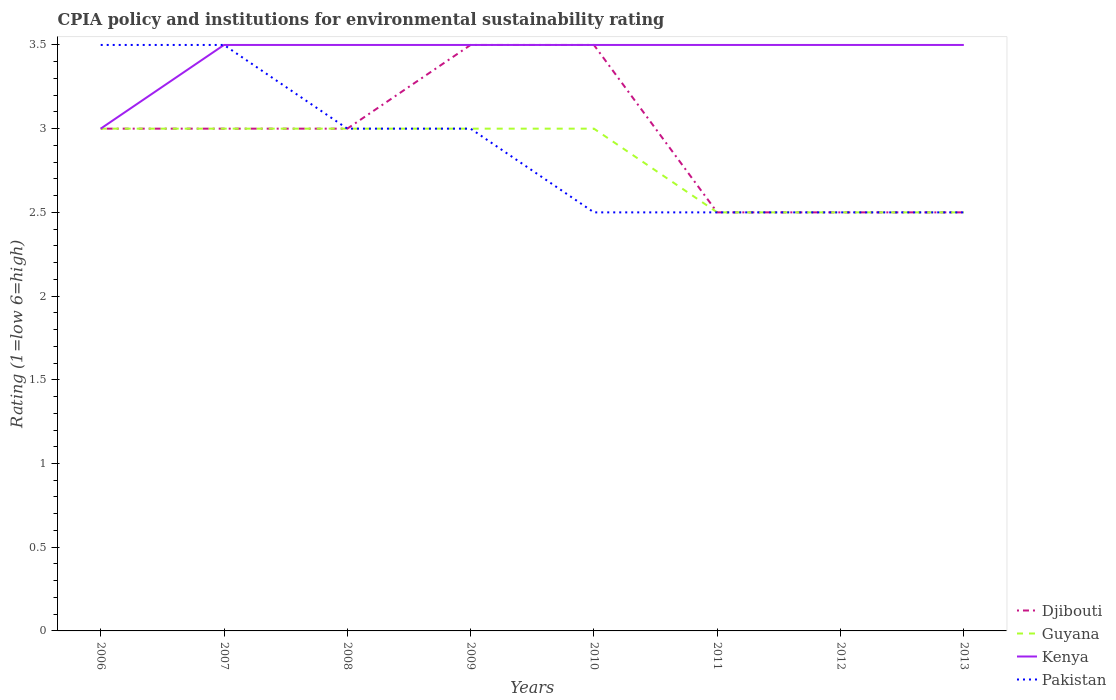How many different coloured lines are there?
Give a very brief answer. 4. Across all years, what is the maximum CPIA rating in Pakistan?
Your response must be concise. 2.5. What is the total CPIA rating in Guyana in the graph?
Give a very brief answer. 0. How many lines are there?
Give a very brief answer. 4. Are the values on the major ticks of Y-axis written in scientific E-notation?
Your response must be concise. No. Does the graph contain grids?
Provide a succinct answer. No. Where does the legend appear in the graph?
Give a very brief answer. Bottom right. How are the legend labels stacked?
Ensure brevity in your answer.  Vertical. What is the title of the graph?
Give a very brief answer. CPIA policy and institutions for environmental sustainability rating. Does "Morocco" appear as one of the legend labels in the graph?
Ensure brevity in your answer.  No. What is the label or title of the X-axis?
Provide a succinct answer. Years. What is the Rating (1=low 6=high) of Guyana in 2007?
Ensure brevity in your answer.  3. What is the Rating (1=low 6=high) in Pakistan in 2007?
Provide a succinct answer. 3.5. What is the Rating (1=low 6=high) in Djibouti in 2009?
Offer a very short reply. 3.5. What is the Rating (1=low 6=high) in Guyana in 2009?
Your answer should be compact. 3. What is the Rating (1=low 6=high) in Kenya in 2009?
Give a very brief answer. 3.5. What is the Rating (1=low 6=high) in Djibouti in 2010?
Provide a succinct answer. 3.5. What is the Rating (1=low 6=high) of Guyana in 2010?
Ensure brevity in your answer.  3. What is the Rating (1=low 6=high) in Djibouti in 2011?
Your answer should be very brief. 2.5. What is the Rating (1=low 6=high) in Guyana in 2011?
Keep it short and to the point. 2.5. What is the Rating (1=low 6=high) of Pakistan in 2011?
Your answer should be very brief. 2.5. What is the Rating (1=low 6=high) of Djibouti in 2013?
Your answer should be compact. 2.5. What is the Rating (1=low 6=high) of Guyana in 2013?
Make the answer very short. 2.5. What is the Rating (1=low 6=high) of Pakistan in 2013?
Ensure brevity in your answer.  2.5. Across all years, what is the maximum Rating (1=low 6=high) of Djibouti?
Your response must be concise. 3.5. Across all years, what is the maximum Rating (1=low 6=high) in Guyana?
Give a very brief answer. 3. Across all years, what is the minimum Rating (1=low 6=high) of Guyana?
Your answer should be very brief. 2.5. Across all years, what is the minimum Rating (1=low 6=high) of Kenya?
Your response must be concise. 3. What is the total Rating (1=low 6=high) of Djibouti in the graph?
Provide a succinct answer. 23.5. What is the total Rating (1=low 6=high) of Kenya in the graph?
Provide a short and direct response. 27.5. What is the difference between the Rating (1=low 6=high) in Djibouti in 2006 and that in 2007?
Offer a terse response. 0. What is the difference between the Rating (1=low 6=high) in Guyana in 2006 and that in 2007?
Offer a very short reply. 0. What is the difference between the Rating (1=low 6=high) of Pakistan in 2006 and that in 2007?
Offer a terse response. 0. What is the difference between the Rating (1=low 6=high) of Guyana in 2006 and that in 2008?
Your answer should be compact. 0. What is the difference between the Rating (1=low 6=high) of Pakistan in 2006 and that in 2008?
Offer a terse response. 0.5. What is the difference between the Rating (1=low 6=high) in Kenya in 2006 and that in 2009?
Provide a short and direct response. -0.5. What is the difference between the Rating (1=low 6=high) of Pakistan in 2006 and that in 2009?
Your answer should be very brief. 0.5. What is the difference between the Rating (1=low 6=high) of Guyana in 2006 and that in 2010?
Provide a short and direct response. 0. What is the difference between the Rating (1=low 6=high) in Kenya in 2006 and that in 2010?
Offer a terse response. -0.5. What is the difference between the Rating (1=low 6=high) in Guyana in 2006 and that in 2011?
Provide a succinct answer. 0.5. What is the difference between the Rating (1=low 6=high) in Kenya in 2006 and that in 2011?
Give a very brief answer. -0.5. What is the difference between the Rating (1=low 6=high) of Kenya in 2006 and that in 2012?
Ensure brevity in your answer.  -0.5. What is the difference between the Rating (1=low 6=high) in Kenya in 2006 and that in 2013?
Your answer should be compact. -0.5. What is the difference between the Rating (1=low 6=high) of Pakistan in 2006 and that in 2013?
Offer a terse response. 1. What is the difference between the Rating (1=low 6=high) in Kenya in 2007 and that in 2008?
Provide a succinct answer. 0. What is the difference between the Rating (1=low 6=high) in Pakistan in 2007 and that in 2008?
Provide a succinct answer. 0.5. What is the difference between the Rating (1=low 6=high) in Djibouti in 2007 and that in 2009?
Offer a very short reply. -0.5. What is the difference between the Rating (1=low 6=high) in Guyana in 2007 and that in 2009?
Offer a terse response. 0. What is the difference between the Rating (1=low 6=high) in Kenya in 2007 and that in 2009?
Your answer should be very brief. 0. What is the difference between the Rating (1=low 6=high) in Guyana in 2007 and that in 2010?
Ensure brevity in your answer.  0. What is the difference between the Rating (1=low 6=high) of Kenya in 2007 and that in 2010?
Offer a terse response. 0. What is the difference between the Rating (1=low 6=high) of Djibouti in 2007 and that in 2011?
Provide a succinct answer. 0.5. What is the difference between the Rating (1=low 6=high) in Guyana in 2007 and that in 2011?
Your answer should be compact. 0.5. What is the difference between the Rating (1=low 6=high) in Pakistan in 2007 and that in 2011?
Your answer should be very brief. 1. What is the difference between the Rating (1=low 6=high) of Guyana in 2007 and that in 2012?
Keep it short and to the point. 0.5. What is the difference between the Rating (1=low 6=high) in Djibouti in 2007 and that in 2013?
Your answer should be very brief. 0.5. What is the difference between the Rating (1=low 6=high) in Kenya in 2007 and that in 2013?
Provide a short and direct response. 0. What is the difference between the Rating (1=low 6=high) of Pakistan in 2008 and that in 2010?
Offer a terse response. 0.5. What is the difference between the Rating (1=low 6=high) of Guyana in 2008 and that in 2011?
Provide a short and direct response. 0.5. What is the difference between the Rating (1=low 6=high) in Kenya in 2008 and that in 2011?
Provide a short and direct response. 0. What is the difference between the Rating (1=low 6=high) of Djibouti in 2008 and that in 2012?
Make the answer very short. 0.5. What is the difference between the Rating (1=low 6=high) in Guyana in 2008 and that in 2012?
Your answer should be compact. 0.5. What is the difference between the Rating (1=low 6=high) in Pakistan in 2008 and that in 2012?
Offer a very short reply. 0.5. What is the difference between the Rating (1=low 6=high) of Djibouti in 2008 and that in 2013?
Your answer should be compact. 0.5. What is the difference between the Rating (1=low 6=high) in Kenya in 2008 and that in 2013?
Provide a succinct answer. 0. What is the difference between the Rating (1=low 6=high) in Pakistan in 2008 and that in 2013?
Keep it short and to the point. 0.5. What is the difference between the Rating (1=low 6=high) in Pakistan in 2009 and that in 2010?
Give a very brief answer. 0.5. What is the difference between the Rating (1=low 6=high) in Kenya in 2009 and that in 2011?
Give a very brief answer. 0. What is the difference between the Rating (1=low 6=high) in Guyana in 2009 and that in 2012?
Give a very brief answer. 0.5. What is the difference between the Rating (1=low 6=high) of Guyana in 2009 and that in 2013?
Provide a succinct answer. 0.5. What is the difference between the Rating (1=low 6=high) of Kenya in 2009 and that in 2013?
Your response must be concise. 0. What is the difference between the Rating (1=low 6=high) of Pakistan in 2009 and that in 2013?
Your answer should be compact. 0.5. What is the difference between the Rating (1=low 6=high) of Djibouti in 2010 and that in 2011?
Offer a terse response. 1. What is the difference between the Rating (1=low 6=high) of Djibouti in 2010 and that in 2013?
Offer a terse response. 1. What is the difference between the Rating (1=low 6=high) in Kenya in 2010 and that in 2013?
Keep it short and to the point. 0. What is the difference between the Rating (1=low 6=high) in Kenya in 2011 and that in 2012?
Make the answer very short. 0. What is the difference between the Rating (1=low 6=high) in Kenya in 2011 and that in 2013?
Your answer should be very brief. 0. What is the difference between the Rating (1=low 6=high) in Djibouti in 2012 and that in 2013?
Keep it short and to the point. 0. What is the difference between the Rating (1=low 6=high) of Djibouti in 2006 and the Rating (1=low 6=high) of Guyana in 2007?
Keep it short and to the point. 0. What is the difference between the Rating (1=low 6=high) of Kenya in 2006 and the Rating (1=low 6=high) of Pakistan in 2007?
Ensure brevity in your answer.  -0.5. What is the difference between the Rating (1=low 6=high) in Djibouti in 2006 and the Rating (1=low 6=high) in Kenya in 2008?
Offer a terse response. -0.5. What is the difference between the Rating (1=low 6=high) of Djibouti in 2006 and the Rating (1=low 6=high) of Pakistan in 2008?
Give a very brief answer. 0. What is the difference between the Rating (1=low 6=high) of Guyana in 2006 and the Rating (1=low 6=high) of Kenya in 2008?
Your answer should be very brief. -0.5. What is the difference between the Rating (1=low 6=high) in Guyana in 2006 and the Rating (1=low 6=high) in Pakistan in 2008?
Provide a short and direct response. 0. What is the difference between the Rating (1=low 6=high) of Djibouti in 2006 and the Rating (1=low 6=high) of Kenya in 2009?
Offer a terse response. -0.5. What is the difference between the Rating (1=low 6=high) in Guyana in 2006 and the Rating (1=low 6=high) in Pakistan in 2009?
Keep it short and to the point. 0. What is the difference between the Rating (1=low 6=high) in Djibouti in 2006 and the Rating (1=low 6=high) in Pakistan in 2010?
Provide a short and direct response. 0.5. What is the difference between the Rating (1=low 6=high) in Guyana in 2006 and the Rating (1=low 6=high) in Pakistan in 2010?
Make the answer very short. 0.5. What is the difference between the Rating (1=low 6=high) in Djibouti in 2006 and the Rating (1=low 6=high) in Guyana in 2011?
Make the answer very short. 0.5. What is the difference between the Rating (1=low 6=high) in Djibouti in 2006 and the Rating (1=low 6=high) in Kenya in 2011?
Ensure brevity in your answer.  -0.5. What is the difference between the Rating (1=low 6=high) of Djibouti in 2006 and the Rating (1=low 6=high) of Kenya in 2012?
Ensure brevity in your answer.  -0.5. What is the difference between the Rating (1=low 6=high) of Djibouti in 2006 and the Rating (1=low 6=high) of Pakistan in 2012?
Your response must be concise. 0.5. What is the difference between the Rating (1=low 6=high) of Guyana in 2006 and the Rating (1=low 6=high) of Kenya in 2012?
Your answer should be very brief. -0.5. What is the difference between the Rating (1=low 6=high) in Djibouti in 2006 and the Rating (1=low 6=high) in Guyana in 2013?
Ensure brevity in your answer.  0.5. What is the difference between the Rating (1=low 6=high) of Djibouti in 2006 and the Rating (1=low 6=high) of Kenya in 2013?
Ensure brevity in your answer.  -0.5. What is the difference between the Rating (1=low 6=high) of Djibouti in 2006 and the Rating (1=low 6=high) of Pakistan in 2013?
Offer a very short reply. 0.5. What is the difference between the Rating (1=low 6=high) of Kenya in 2006 and the Rating (1=low 6=high) of Pakistan in 2013?
Provide a short and direct response. 0.5. What is the difference between the Rating (1=low 6=high) in Djibouti in 2007 and the Rating (1=low 6=high) in Guyana in 2008?
Offer a terse response. 0. What is the difference between the Rating (1=low 6=high) of Djibouti in 2007 and the Rating (1=low 6=high) of Kenya in 2008?
Your response must be concise. -0.5. What is the difference between the Rating (1=low 6=high) of Djibouti in 2007 and the Rating (1=low 6=high) of Pakistan in 2008?
Offer a terse response. 0. What is the difference between the Rating (1=low 6=high) of Kenya in 2007 and the Rating (1=low 6=high) of Pakistan in 2008?
Offer a very short reply. 0.5. What is the difference between the Rating (1=low 6=high) of Djibouti in 2007 and the Rating (1=low 6=high) of Pakistan in 2009?
Provide a short and direct response. 0. What is the difference between the Rating (1=low 6=high) of Guyana in 2007 and the Rating (1=low 6=high) of Pakistan in 2009?
Your answer should be compact. 0. What is the difference between the Rating (1=low 6=high) of Djibouti in 2007 and the Rating (1=low 6=high) of Guyana in 2010?
Keep it short and to the point. 0. What is the difference between the Rating (1=low 6=high) in Djibouti in 2007 and the Rating (1=low 6=high) in Pakistan in 2010?
Your answer should be very brief. 0.5. What is the difference between the Rating (1=low 6=high) in Djibouti in 2007 and the Rating (1=low 6=high) in Kenya in 2011?
Make the answer very short. -0.5. What is the difference between the Rating (1=low 6=high) in Djibouti in 2007 and the Rating (1=low 6=high) in Pakistan in 2011?
Your answer should be compact. 0.5. What is the difference between the Rating (1=low 6=high) of Guyana in 2007 and the Rating (1=low 6=high) of Kenya in 2011?
Offer a terse response. -0.5. What is the difference between the Rating (1=low 6=high) in Guyana in 2007 and the Rating (1=low 6=high) in Pakistan in 2011?
Your answer should be compact. 0.5. What is the difference between the Rating (1=low 6=high) of Djibouti in 2007 and the Rating (1=low 6=high) of Guyana in 2012?
Provide a short and direct response. 0.5. What is the difference between the Rating (1=low 6=high) in Djibouti in 2007 and the Rating (1=low 6=high) in Kenya in 2012?
Your response must be concise. -0.5. What is the difference between the Rating (1=low 6=high) of Kenya in 2007 and the Rating (1=low 6=high) of Pakistan in 2012?
Your answer should be compact. 1. What is the difference between the Rating (1=low 6=high) in Djibouti in 2007 and the Rating (1=low 6=high) in Kenya in 2013?
Give a very brief answer. -0.5. What is the difference between the Rating (1=low 6=high) in Djibouti in 2007 and the Rating (1=low 6=high) in Pakistan in 2013?
Provide a short and direct response. 0.5. What is the difference between the Rating (1=low 6=high) of Guyana in 2007 and the Rating (1=low 6=high) of Pakistan in 2013?
Provide a succinct answer. 0.5. What is the difference between the Rating (1=low 6=high) of Djibouti in 2008 and the Rating (1=low 6=high) of Guyana in 2009?
Your response must be concise. 0. What is the difference between the Rating (1=low 6=high) in Djibouti in 2008 and the Rating (1=low 6=high) in Kenya in 2009?
Ensure brevity in your answer.  -0.5. What is the difference between the Rating (1=low 6=high) of Djibouti in 2008 and the Rating (1=low 6=high) of Pakistan in 2009?
Ensure brevity in your answer.  0. What is the difference between the Rating (1=low 6=high) in Guyana in 2008 and the Rating (1=low 6=high) in Kenya in 2009?
Your answer should be compact. -0.5. What is the difference between the Rating (1=low 6=high) in Kenya in 2008 and the Rating (1=low 6=high) in Pakistan in 2009?
Keep it short and to the point. 0.5. What is the difference between the Rating (1=low 6=high) of Djibouti in 2008 and the Rating (1=low 6=high) of Kenya in 2010?
Offer a very short reply. -0.5. What is the difference between the Rating (1=low 6=high) of Guyana in 2008 and the Rating (1=low 6=high) of Pakistan in 2010?
Your answer should be compact. 0.5. What is the difference between the Rating (1=low 6=high) in Kenya in 2008 and the Rating (1=low 6=high) in Pakistan in 2010?
Your answer should be compact. 1. What is the difference between the Rating (1=low 6=high) of Djibouti in 2008 and the Rating (1=low 6=high) of Kenya in 2011?
Give a very brief answer. -0.5. What is the difference between the Rating (1=low 6=high) in Guyana in 2008 and the Rating (1=low 6=high) in Pakistan in 2012?
Offer a terse response. 0.5. What is the difference between the Rating (1=low 6=high) in Djibouti in 2008 and the Rating (1=low 6=high) in Kenya in 2013?
Your answer should be compact. -0.5. What is the difference between the Rating (1=low 6=high) of Kenya in 2008 and the Rating (1=low 6=high) of Pakistan in 2013?
Your answer should be compact. 1. What is the difference between the Rating (1=low 6=high) of Djibouti in 2009 and the Rating (1=low 6=high) of Pakistan in 2010?
Provide a succinct answer. 1. What is the difference between the Rating (1=low 6=high) of Kenya in 2009 and the Rating (1=low 6=high) of Pakistan in 2010?
Offer a terse response. 1. What is the difference between the Rating (1=low 6=high) in Djibouti in 2009 and the Rating (1=low 6=high) in Guyana in 2012?
Make the answer very short. 1. What is the difference between the Rating (1=low 6=high) of Guyana in 2009 and the Rating (1=low 6=high) of Kenya in 2012?
Provide a short and direct response. -0.5. What is the difference between the Rating (1=low 6=high) of Kenya in 2009 and the Rating (1=low 6=high) of Pakistan in 2012?
Offer a terse response. 1. What is the difference between the Rating (1=low 6=high) of Djibouti in 2009 and the Rating (1=low 6=high) of Guyana in 2013?
Give a very brief answer. 1. What is the difference between the Rating (1=low 6=high) of Djibouti in 2009 and the Rating (1=low 6=high) of Kenya in 2013?
Ensure brevity in your answer.  0. What is the difference between the Rating (1=low 6=high) in Djibouti in 2009 and the Rating (1=low 6=high) in Pakistan in 2013?
Make the answer very short. 1. What is the difference between the Rating (1=low 6=high) of Guyana in 2009 and the Rating (1=low 6=high) of Kenya in 2013?
Your answer should be very brief. -0.5. What is the difference between the Rating (1=low 6=high) in Kenya in 2009 and the Rating (1=low 6=high) in Pakistan in 2013?
Ensure brevity in your answer.  1. What is the difference between the Rating (1=low 6=high) in Djibouti in 2010 and the Rating (1=low 6=high) in Guyana in 2011?
Give a very brief answer. 1. What is the difference between the Rating (1=low 6=high) in Guyana in 2010 and the Rating (1=low 6=high) in Kenya in 2011?
Keep it short and to the point. -0.5. What is the difference between the Rating (1=low 6=high) of Guyana in 2010 and the Rating (1=low 6=high) of Pakistan in 2011?
Offer a very short reply. 0.5. What is the difference between the Rating (1=low 6=high) in Kenya in 2010 and the Rating (1=low 6=high) in Pakistan in 2011?
Provide a succinct answer. 1. What is the difference between the Rating (1=low 6=high) of Djibouti in 2010 and the Rating (1=low 6=high) of Guyana in 2012?
Make the answer very short. 1. What is the difference between the Rating (1=low 6=high) in Djibouti in 2010 and the Rating (1=low 6=high) in Kenya in 2012?
Your answer should be compact. 0. What is the difference between the Rating (1=low 6=high) in Guyana in 2010 and the Rating (1=low 6=high) in Kenya in 2012?
Provide a short and direct response. -0.5. What is the difference between the Rating (1=low 6=high) in Guyana in 2010 and the Rating (1=low 6=high) in Pakistan in 2012?
Provide a short and direct response. 0.5. What is the difference between the Rating (1=low 6=high) in Djibouti in 2010 and the Rating (1=low 6=high) in Guyana in 2013?
Keep it short and to the point. 1. What is the difference between the Rating (1=low 6=high) in Kenya in 2010 and the Rating (1=low 6=high) in Pakistan in 2013?
Make the answer very short. 1. What is the difference between the Rating (1=low 6=high) in Djibouti in 2011 and the Rating (1=low 6=high) in Kenya in 2012?
Make the answer very short. -1. What is the difference between the Rating (1=low 6=high) of Djibouti in 2011 and the Rating (1=low 6=high) of Pakistan in 2012?
Keep it short and to the point. 0. What is the difference between the Rating (1=low 6=high) in Kenya in 2011 and the Rating (1=low 6=high) in Pakistan in 2012?
Provide a succinct answer. 1. What is the difference between the Rating (1=low 6=high) of Djibouti in 2011 and the Rating (1=low 6=high) of Guyana in 2013?
Offer a terse response. 0. What is the difference between the Rating (1=low 6=high) in Djibouti in 2011 and the Rating (1=low 6=high) in Kenya in 2013?
Your answer should be very brief. -1. What is the difference between the Rating (1=low 6=high) of Djibouti in 2011 and the Rating (1=low 6=high) of Pakistan in 2013?
Ensure brevity in your answer.  0. What is the difference between the Rating (1=low 6=high) of Guyana in 2011 and the Rating (1=low 6=high) of Pakistan in 2013?
Offer a very short reply. 0. What is the difference between the Rating (1=low 6=high) of Djibouti in 2012 and the Rating (1=low 6=high) of Pakistan in 2013?
Ensure brevity in your answer.  0. What is the average Rating (1=low 6=high) of Djibouti per year?
Keep it short and to the point. 2.94. What is the average Rating (1=low 6=high) in Guyana per year?
Your answer should be compact. 2.81. What is the average Rating (1=low 6=high) of Kenya per year?
Offer a very short reply. 3.44. What is the average Rating (1=low 6=high) in Pakistan per year?
Ensure brevity in your answer.  2.88. In the year 2006, what is the difference between the Rating (1=low 6=high) in Djibouti and Rating (1=low 6=high) in Kenya?
Your answer should be very brief. 0. In the year 2006, what is the difference between the Rating (1=low 6=high) in Guyana and Rating (1=low 6=high) in Kenya?
Keep it short and to the point. 0. In the year 2006, what is the difference between the Rating (1=low 6=high) of Kenya and Rating (1=low 6=high) of Pakistan?
Make the answer very short. -0.5. In the year 2007, what is the difference between the Rating (1=low 6=high) of Djibouti and Rating (1=low 6=high) of Pakistan?
Provide a short and direct response. -0.5. In the year 2007, what is the difference between the Rating (1=low 6=high) in Guyana and Rating (1=low 6=high) in Kenya?
Ensure brevity in your answer.  -0.5. In the year 2008, what is the difference between the Rating (1=low 6=high) of Djibouti and Rating (1=low 6=high) of Kenya?
Provide a succinct answer. -0.5. In the year 2008, what is the difference between the Rating (1=low 6=high) in Guyana and Rating (1=low 6=high) in Pakistan?
Give a very brief answer. 0. In the year 2008, what is the difference between the Rating (1=low 6=high) in Kenya and Rating (1=low 6=high) in Pakistan?
Offer a very short reply. 0.5. In the year 2009, what is the difference between the Rating (1=low 6=high) in Djibouti and Rating (1=low 6=high) in Pakistan?
Provide a succinct answer. 0.5. In the year 2009, what is the difference between the Rating (1=low 6=high) of Guyana and Rating (1=low 6=high) of Kenya?
Your response must be concise. -0.5. In the year 2009, what is the difference between the Rating (1=low 6=high) of Guyana and Rating (1=low 6=high) of Pakistan?
Keep it short and to the point. 0. In the year 2010, what is the difference between the Rating (1=low 6=high) of Djibouti and Rating (1=low 6=high) of Kenya?
Ensure brevity in your answer.  0. In the year 2010, what is the difference between the Rating (1=low 6=high) of Guyana and Rating (1=low 6=high) of Pakistan?
Your answer should be very brief. 0.5. In the year 2010, what is the difference between the Rating (1=low 6=high) in Kenya and Rating (1=low 6=high) in Pakistan?
Make the answer very short. 1. In the year 2011, what is the difference between the Rating (1=low 6=high) of Djibouti and Rating (1=low 6=high) of Guyana?
Keep it short and to the point. 0. In the year 2011, what is the difference between the Rating (1=low 6=high) in Djibouti and Rating (1=low 6=high) in Kenya?
Offer a terse response. -1. In the year 2011, what is the difference between the Rating (1=low 6=high) of Guyana and Rating (1=low 6=high) of Kenya?
Provide a short and direct response. -1. In the year 2012, what is the difference between the Rating (1=low 6=high) of Djibouti and Rating (1=low 6=high) of Guyana?
Give a very brief answer. 0. In the year 2012, what is the difference between the Rating (1=low 6=high) in Djibouti and Rating (1=low 6=high) in Pakistan?
Make the answer very short. 0. In the year 2012, what is the difference between the Rating (1=low 6=high) in Kenya and Rating (1=low 6=high) in Pakistan?
Provide a short and direct response. 1. In the year 2013, what is the difference between the Rating (1=low 6=high) in Djibouti and Rating (1=low 6=high) in Kenya?
Ensure brevity in your answer.  -1. In the year 2013, what is the difference between the Rating (1=low 6=high) of Guyana and Rating (1=low 6=high) of Kenya?
Your answer should be very brief. -1. In the year 2013, what is the difference between the Rating (1=low 6=high) in Guyana and Rating (1=low 6=high) in Pakistan?
Keep it short and to the point. 0. In the year 2013, what is the difference between the Rating (1=low 6=high) of Kenya and Rating (1=low 6=high) of Pakistan?
Offer a very short reply. 1. What is the ratio of the Rating (1=low 6=high) of Djibouti in 2006 to that in 2007?
Offer a very short reply. 1. What is the ratio of the Rating (1=low 6=high) in Pakistan in 2006 to that in 2007?
Offer a very short reply. 1. What is the ratio of the Rating (1=low 6=high) in Pakistan in 2006 to that in 2008?
Provide a short and direct response. 1.17. What is the ratio of the Rating (1=low 6=high) in Djibouti in 2006 to that in 2009?
Offer a very short reply. 0.86. What is the ratio of the Rating (1=low 6=high) of Guyana in 2006 to that in 2009?
Keep it short and to the point. 1. What is the ratio of the Rating (1=low 6=high) in Kenya in 2006 to that in 2009?
Your answer should be compact. 0.86. What is the ratio of the Rating (1=low 6=high) in Kenya in 2006 to that in 2010?
Ensure brevity in your answer.  0.86. What is the ratio of the Rating (1=low 6=high) of Kenya in 2006 to that in 2011?
Provide a short and direct response. 0.86. What is the ratio of the Rating (1=low 6=high) of Pakistan in 2006 to that in 2011?
Make the answer very short. 1.4. What is the ratio of the Rating (1=low 6=high) of Djibouti in 2006 to that in 2012?
Offer a terse response. 1.2. What is the ratio of the Rating (1=low 6=high) of Pakistan in 2006 to that in 2012?
Ensure brevity in your answer.  1.4. What is the ratio of the Rating (1=low 6=high) in Djibouti in 2006 to that in 2013?
Your answer should be compact. 1.2. What is the ratio of the Rating (1=low 6=high) in Guyana in 2006 to that in 2013?
Make the answer very short. 1.2. What is the ratio of the Rating (1=low 6=high) of Guyana in 2007 to that in 2008?
Offer a terse response. 1. What is the ratio of the Rating (1=low 6=high) of Kenya in 2007 to that in 2008?
Offer a terse response. 1. What is the ratio of the Rating (1=low 6=high) in Djibouti in 2007 to that in 2009?
Ensure brevity in your answer.  0.86. What is the ratio of the Rating (1=low 6=high) in Kenya in 2007 to that in 2009?
Your response must be concise. 1. What is the ratio of the Rating (1=low 6=high) of Kenya in 2007 to that in 2010?
Your response must be concise. 1. What is the ratio of the Rating (1=low 6=high) in Djibouti in 2007 to that in 2011?
Your response must be concise. 1.2. What is the ratio of the Rating (1=low 6=high) of Guyana in 2007 to that in 2011?
Keep it short and to the point. 1.2. What is the ratio of the Rating (1=low 6=high) in Pakistan in 2007 to that in 2011?
Keep it short and to the point. 1.4. What is the ratio of the Rating (1=low 6=high) in Djibouti in 2007 to that in 2012?
Ensure brevity in your answer.  1.2. What is the ratio of the Rating (1=low 6=high) in Djibouti in 2007 to that in 2013?
Keep it short and to the point. 1.2. What is the ratio of the Rating (1=low 6=high) of Guyana in 2007 to that in 2013?
Your answer should be compact. 1.2. What is the ratio of the Rating (1=low 6=high) of Kenya in 2007 to that in 2013?
Make the answer very short. 1. What is the ratio of the Rating (1=low 6=high) of Pakistan in 2007 to that in 2013?
Give a very brief answer. 1.4. What is the ratio of the Rating (1=low 6=high) of Pakistan in 2008 to that in 2009?
Give a very brief answer. 1. What is the ratio of the Rating (1=low 6=high) of Djibouti in 2008 to that in 2010?
Your response must be concise. 0.86. What is the ratio of the Rating (1=low 6=high) in Guyana in 2008 to that in 2010?
Your answer should be compact. 1. What is the ratio of the Rating (1=low 6=high) in Kenya in 2008 to that in 2010?
Your answer should be very brief. 1. What is the ratio of the Rating (1=low 6=high) of Djibouti in 2008 to that in 2011?
Ensure brevity in your answer.  1.2. What is the ratio of the Rating (1=low 6=high) of Kenya in 2008 to that in 2011?
Keep it short and to the point. 1. What is the ratio of the Rating (1=low 6=high) in Djibouti in 2008 to that in 2012?
Your response must be concise. 1.2. What is the ratio of the Rating (1=low 6=high) of Kenya in 2008 to that in 2013?
Ensure brevity in your answer.  1. What is the ratio of the Rating (1=low 6=high) of Pakistan in 2008 to that in 2013?
Your answer should be very brief. 1.2. What is the ratio of the Rating (1=low 6=high) in Djibouti in 2009 to that in 2010?
Keep it short and to the point. 1. What is the ratio of the Rating (1=low 6=high) of Guyana in 2009 to that in 2010?
Give a very brief answer. 1. What is the ratio of the Rating (1=low 6=high) in Pakistan in 2009 to that in 2010?
Your answer should be very brief. 1.2. What is the ratio of the Rating (1=low 6=high) of Djibouti in 2009 to that in 2011?
Make the answer very short. 1.4. What is the ratio of the Rating (1=low 6=high) of Kenya in 2009 to that in 2011?
Give a very brief answer. 1. What is the ratio of the Rating (1=low 6=high) of Djibouti in 2009 to that in 2012?
Provide a succinct answer. 1.4. What is the ratio of the Rating (1=low 6=high) in Guyana in 2009 to that in 2012?
Provide a succinct answer. 1.2. What is the ratio of the Rating (1=low 6=high) of Kenya in 2009 to that in 2012?
Your answer should be compact. 1. What is the ratio of the Rating (1=low 6=high) of Pakistan in 2009 to that in 2012?
Provide a succinct answer. 1.2. What is the ratio of the Rating (1=low 6=high) of Kenya in 2010 to that in 2011?
Keep it short and to the point. 1. What is the ratio of the Rating (1=low 6=high) in Djibouti in 2010 to that in 2013?
Offer a very short reply. 1.4. What is the ratio of the Rating (1=low 6=high) in Guyana in 2010 to that in 2013?
Ensure brevity in your answer.  1.2. What is the ratio of the Rating (1=low 6=high) in Kenya in 2010 to that in 2013?
Offer a very short reply. 1. What is the ratio of the Rating (1=low 6=high) of Djibouti in 2011 to that in 2012?
Offer a very short reply. 1. What is the ratio of the Rating (1=low 6=high) in Kenya in 2011 to that in 2012?
Your answer should be very brief. 1. What is the ratio of the Rating (1=low 6=high) in Djibouti in 2011 to that in 2013?
Your response must be concise. 1. What is the ratio of the Rating (1=low 6=high) of Kenya in 2011 to that in 2013?
Offer a terse response. 1. What is the ratio of the Rating (1=low 6=high) of Guyana in 2012 to that in 2013?
Your answer should be compact. 1. What is the ratio of the Rating (1=low 6=high) in Kenya in 2012 to that in 2013?
Provide a short and direct response. 1. What is the ratio of the Rating (1=low 6=high) in Pakistan in 2012 to that in 2013?
Your answer should be very brief. 1. What is the difference between the highest and the second highest Rating (1=low 6=high) in Djibouti?
Keep it short and to the point. 0. What is the difference between the highest and the second highest Rating (1=low 6=high) of Guyana?
Make the answer very short. 0. What is the difference between the highest and the second highest Rating (1=low 6=high) in Kenya?
Your response must be concise. 0. What is the difference between the highest and the second highest Rating (1=low 6=high) in Pakistan?
Your response must be concise. 0. What is the difference between the highest and the lowest Rating (1=low 6=high) of Kenya?
Make the answer very short. 0.5. 